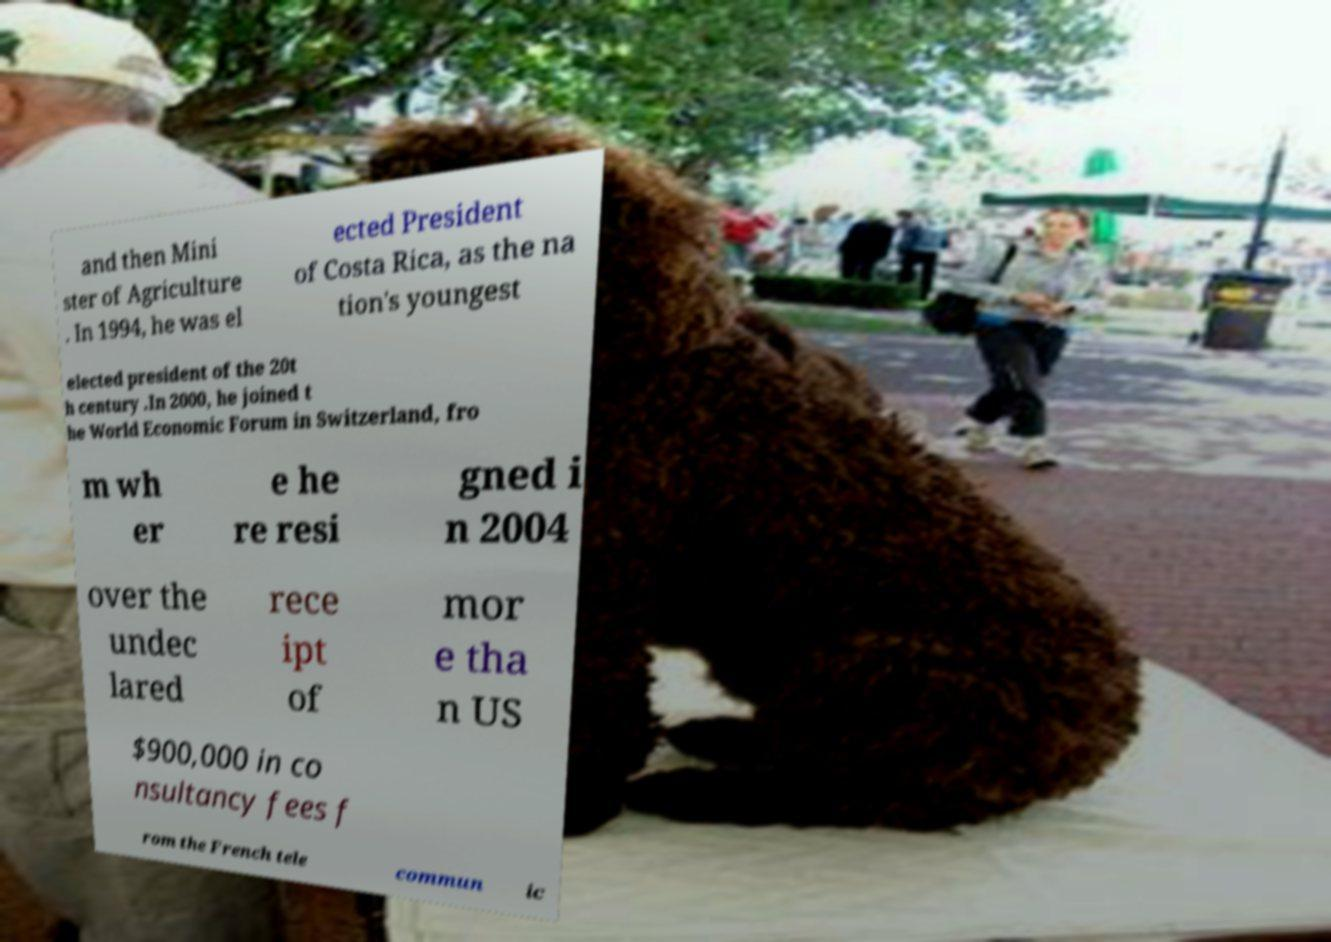I need the written content from this picture converted into text. Can you do that? and then Mini ster of Agriculture . In 1994, he was el ected President of Costa Rica, as the na tion's youngest elected president of the 20t h century .In 2000, he joined t he World Economic Forum in Switzerland, fro m wh er e he re resi gned i n 2004 over the undec lared rece ipt of mor e tha n US $900,000 in co nsultancy fees f rom the French tele commun ic 